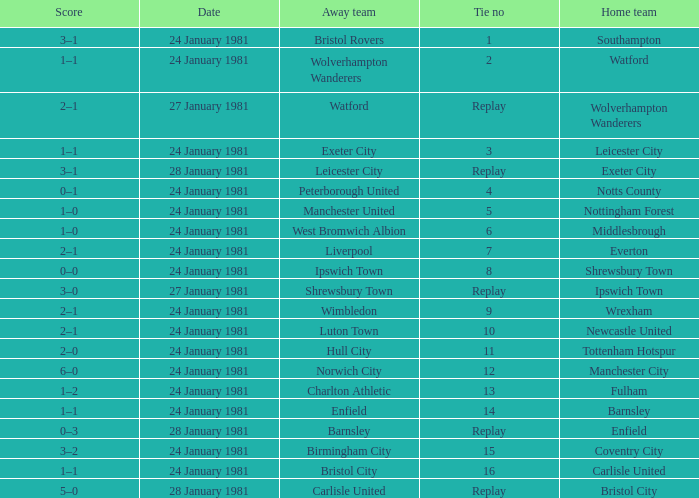What is the score when the tie is 9? 2–1. 